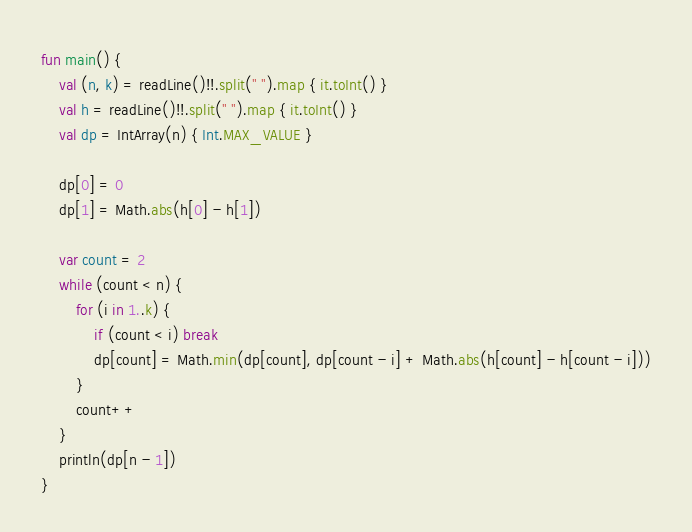Convert code to text. <code><loc_0><loc_0><loc_500><loc_500><_Kotlin_>fun main() {
    val (n, k) = readLine()!!.split(" ").map { it.toInt() }
    val h = readLine()!!.split(" ").map { it.toInt() }
    val dp = IntArray(n) { Int.MAX_VALUE }

    dp[0] = 0
    dp[1] = Math.abs(h[0] - h[1])

    var count = 2
    while (count < n) {
        for (i in 1..k) {
            if (count < i) break
            dp[count] = Math.min(dp[count], dp[count - i] + Math.abs(h[count] - h[count - i]))
        }
        count++
    }
    println(dp[n - 1])
}</code> 